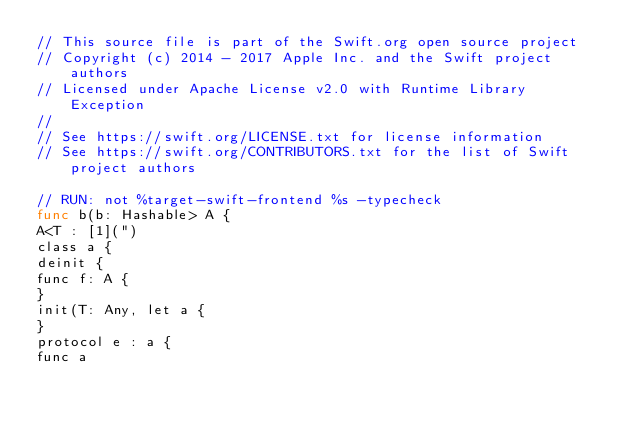<code> <loc_0><loc_0><loc_500><loc_500><_Swift_>// This source file is part of the Swift.org open source project
// Copyright (c) 2014 - 2017 Apple Inc. and the Swift project authors
// Licensed under Apache License v2.0 with Runtime Library Exception
//
// See https://swift.org/LICENSE.txt for license information
// See https://swift.org/CONTRIBUTORS.txt for the list of Swift project authors

// RUN: not %target-swift-frontend %s -typecheck
func b(b: Hashable> A {
A<T : [1](")
class a {
deinit {
func f: A {
}
init(T: Any, let a {
}
protocol e : a {
func a
</code> 